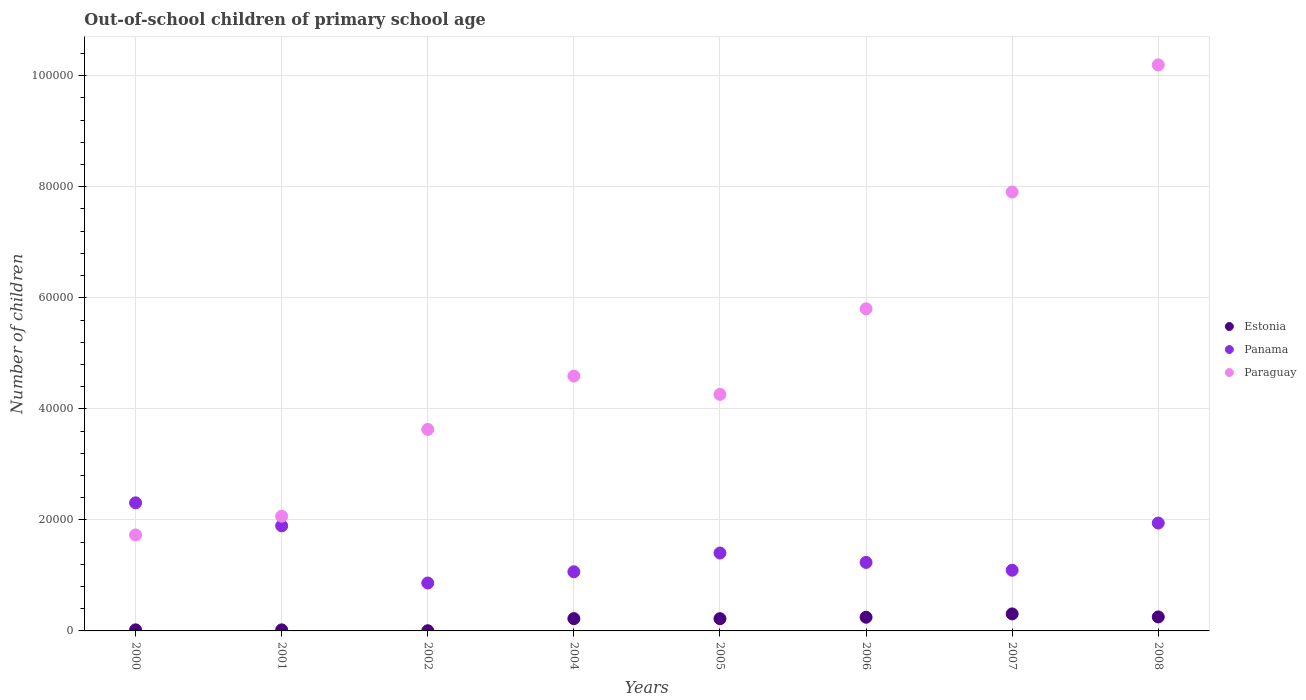Is the number of dotlines equal to the number of legend labels?
Give a very brief answer. Yes. What is the number of out-of-school children in Estonia in 2004?
Your answer should be very brief. 2213. Across all years, what is the maximum number of out-of-school children in Paraguay?
Ensure brevity in your answer.  1.02e+05. Across all years, what is the minimum number of out-of-school children in Estonia?
Your answer should be very brief. 36. What is the total number of out-of-school children in Panama in the graph?
Keep it short and to the point. 1.18e+05. What is the difference between the number of out-of-school children in Estonia in 2001 and that in 2002?
Provide a short and direct response. 156. What is the difference between the number of out-of-school children in Paraguay in 2002 and the number of out-of-school children in Estonia in 2000?
Your answer should be very brief. 3.61e+04. What is the average number of out-of-school children in Estonia per year?
Provide a short and direct response. 1611.12. In the year 2007, what is the difference between the number of out-of-school children in Estonia and number of out-of-school children in Paraguay?
Your response must be concise. -7.60e+04. In how many years, is the number of out-of-school children in Paraguay greater than 60000?
Ensure brevity in your answer.  2. What is the ratio of the number of out-of-school children in Estonia in 2000 to that in 2005?
Your answer should be compact. 0.09. Is the number of out-of-school children in Estonia in 2005 less than that in 2008?
Ensure brevity in your answer.  Yes. What is the difference between the highest and the second highest number of out-of-school children in Estonia?
Offer a very short reply. 546. What is the difference between the highest and the lowest number of out-of-school children in Paraguay?
Make the answer very short. 8.47e+04. Is the number of out-of-school children in Paraguay strictly greater than the number of out-of-school children in Panama over the years?
Keep it short and to the point. No. How many dotlines are there?
Provide a succinct answer. 3. How many years are there in the graph?
Your answer should be very brief. 8. What is the difference between two consecutive major ticks on the Y-axis?
Make the answer very short. 2.00e+04. Are the values on the major ticks of Y-axis written in scientific E-notation?
Ensure brevity in your answer.  No. Does the graph contain grids?
Offer a very short reply. Yes. How many legend labels are there?
Your answer should be very brief. 3. What is the title of the graph?
Offer a very short reply. Out-of-school children of primary school age. What is the label or title of the Y-axis?
Offer a very short reply. Number of children. What is the Number of children in Estonia in 2000?
Your response must be concise. 193. What is the Number of children in Panama in 2000?
Give a very brief answer. 2.31e+04. What is the Number of children of Paraguay in 2000?
Give a very brief answer. 1.73e+04. What is the Number of children of Estonia in 2001?
Keep it short and to the point. 192. What is the Number of children of Panama in 2001?
Keep it short and to the point. 1.89e+04. What is the Number of children in Paraguay in 2001?
Ensure brevity in your answer.  2.07e+04. What is the Number of children in Estonia in 2002?
Offer a very short reply. 36. What is the Number of children of Panama in 2002?
Keep it short and to the point. 8631. What is the Number of children in Paraguay in 2002?
Your response must be concise. 3.63e+04. What is the Number of children of Estonia in 2004?
Provide a succinct answer. 2213. What is the Number of children of Panama in 2004?
Your answer should be very brief. 1.07e+04. What is the Number of children in Paraguay in 2004?
Make the answer very short. 4.59e+04. What is the Number of children in Estonia in 2005?
Your response must be concise. 2203. What is the Number of children in Panama in 2005?
Your answer should be very brief. 1.40e+04. What is the Number of children in Paraguay in 2005?
Make the answer very short. 4.26e+04. What is the Number of children of Estonia in 2006?
Offer a terse response. 2464. What is the Number of children in Panama in 2006?
Ensure brevity in your answer.  1.23e+04. What is the Number of children of Paraguay in 2006?
Your answer should be very brief. 5.80e+04. What is the Number of children in Estonia in 2007?
Provide a succinct answer. 3067. What is the Number of children in Panama in 2007?
Keep it short and to the point. 1.09e+04. What is the Number of children of Paraguay in 2007?
Ensure brevity in your answer.  7.90e+04. What is the Number of children in Estonia in 2008?
Your response must be concise. 2521. What is the Number of children in Panama in 2008?
Your response must be concise. 1.94e+04. What is the Number of children in Paraguay in 2008?
Your answer should be compact. 1.02e+05. Across all years, what is the maximum Number of children of Estonia?
Make the answer very short. 3067. Across all years, what is the maximum Number of children in Panama?
Keep it short and to the point. 2.31e+04. Across all years, what is the maximum Number of children of Paraguay?
Provide a succinct answer. 1.02e+05. Across all years, what is the minimum Number of children of Panama?
Offer a very short reply. 8631. Across all years, what is the minimum Number of children of Paraguay?
Provide a short and direct response. 1.73e+04. What is the total Number of children in Estonia in the graph?
Provide a succinct answer. 1.29e+04. What is the total Number of children of Panama in the graph?
Make the answer very short. 1.18e+05. What is the total Number of children of Paraguay in the graph?
Provide a short and direct response. 4.02e+05. What is the difference between the Number of children in Panama in 2000 and that in 2001?
Your answer should be very brief. 4151. What is the difference between the Number of children of Paraguay in 2000 and that in 2001?
Your response must be concise. -3367. What is the difference between the Number of children in Estonia in 2000 and that in 2002?
Offer a very short reply. 157. What is the difference between the Number of children in Panama in 2000 and that in 2002?
Ensure brevity in your answer.  1.44e+04. What is the difference between the Number of children in Paraguay in 2000 and that in 2002?
Offer a very short reply. -1.90e+04. What is the difference between the Number of children in Estonia in 2000 and that in 2004?
Offer a very short reply. -2020. What is the difference between the Number of children of Panama in 2000 and that in 2004?
Your answer should be compact. 1.24e+04. What is the difference between the Number of children in Paraguay in 2000 and that in 2004?
Provide a short and direct response. -2.86e+04. What is the difference between the Number of children of Estonia in 2000 and that in 2005?
Provide a succinct answer. -2010. What is the difference between the Number of children of Panama in 2000 and that in 2005?
Make the answer very short. 9039. What is the difference between the Number of children in Paraguay in 2000 and that in 2005?
Your answer should be compact. -2.53e+04. What is the difference between the Number of children of Estonia in 2000 and that in 2006?
Keep it short and to the point. -2271. What is the difference between the Number of children of Panama in 2000 and that in 2006?
Make the answer very short. 1.07e+04. What is the difference between the Number of children in Paraguay in 2000 and that in 2006?
Make the answer very short. -4.07e+04. What is the difference between the Number of children in Estonia in 2000 and that in 2007?
Make the answer very short. -2874. What is the difference between the Number of children in Panama in 2000 and that in 2007?
Provide a short and direct response. 1.21e+04. What is the difference between the Number of children in Paraguay in 2000 and that in 2007?
Offer a terse response. -6.18e+04. What is the difference between the Number of children in Estonia in 2000 and that in 2008?
Offer a terse response. -2328. What is the difference between the Number of children of Panama in 2000 and that in 2008?
Offer a very short reply. 3641. What is the difference between the Number of children in Paraguay in 2000 and that in 2008?
Keep it short and to the point. -8.47e+04. What is the difference between the Number of children in Estonia in 2001 and that in 2002?
Keep it short and to the point. 156. What is the difference between the Number of children in Panama in 2001 and that in 2002?
Make the answer very short. 1.03e+04. What is the difference between the Number of children of Paraguay in 2001 and that in 2002?
Your answer should be compact. -1.56e+04. What is the difference between the Number of children of Estonia in 2001 and that in 2004?
Offer a terse response. -2021. What is the difference between the Number of children of Panama in 2001 and that in 2004?
Offer a terse response. 8267. What is the difference between the Number of children of Paraguay in 2001 and that in 2004?
Give a very brief answer. -2.52e+04. What is the difference between the Number of children in Estonia in 2001 and that in 2005?
Offer a very short reply. -2011. What is the difference between the Number of children of Panama in 2001 and that in 2005?
Keep it short and to the point. 4888. What is the difference between the Number of children of Paraguay in 2001 and that in 2005?
Ensure brevity in your answer.  -2.19e+04. What is the difference between the Number of children of Estonia in 2001 and that in 2006?
Ensure brevity in your answer.  -2272. What is the difference between the Number of children in Panama in 2001 and that in 2006?
Your answer should be compact. 6582. What is the difference between the Number of children of Paraguay in 2001 and that in 2006?
Ensure brevity in your answer.  -3.74e+04. What is the difference between the Number of children in Estonia in 2001 and that in 2007?
Ensure brevity in your answer.  -2875. What is the difference between the Number of children in Panama in 2001 and that in 2007?
Offer a terse response. 7992. What is the difference between the Number of children of Paraguay in 2001 and that in 2007?
Give a very brief answer. -5.84e+04. What is the difference between the Number of children in Estonia in 2001 and that in 2008?
Your response must be concise. -2329. What is the difference between the Number of children of Panama in 2001 and that in 2008?
Give a very brief answer. -510. What is the difference between the Number of children of Paraguay in 2001 and that in 2008?
Make the answer very short. -8.13e+04. What is the difference between the Number of children in Estonia in 2002 and that in 2004?
Offer a very short reply. -2177. What is the difference between the Number of children of Panama in 2002 and that in 2004?
Provide a succinct answer. -2023. What is the difference between the Number of children of Paraguay in 2002 and that in 2004?
Offer a very short reply. -9607. What is the difference between the Number of children of Estonia in 2002 and that in 2005?
Provide a succinct answer. -2167. What is the difference between the Number of children in Panama in 2002 and that in 2005?
Provide a short and direct response. -5402. What is the difference between the Number of children of Paraguay in 2002 and that in 2005?
Your answer should be very brief. -6308. What is the difference between the Number of children in Estonia in 2002 and that in 2006?
Give a very brief answer. -2428. What is the difference between the Number of children in Panama in 2002 and that in 2006?
Keep it short and to the point. -3708. What is the difference between the Number of children of Paraguay in 2002 and that in 2006?
Your answer should be compact. -2.17e+04. What is the difference between the Number of children in Estonia in 2002 and that in 2007?
Offer a very short reply. -3031. What is the difference between the Number of children in Panama in 2002 and that in 2007?
Provide a succinct answer. -2298. What is the difference between the Number of children of Paraguay in 2002 and that in 2007?
Ensure brevity in your answer.  -4.28e+04. What is the difference between the Number of children of Estonia in 2002 and that in 2008?
Give a very brief answer. -2485. What is the difference between the Number of children in Panama in 2002 and that in 2008?
Ensure brevity in your answer.  -1.08e+04. What is the difference between the Number of children in Paraguay in 2002 and that in 2008?
Keep it short and to the point. -6.57e+04. What is the difference between the Number of children of Estonia in 2004 and that in 2005?
Give a very brief answer. 10. What is the difference between the Number of children of Panama in 2004 and that in 2005?
Your response must be concise. -3379. What is the difference between the Number of children in Paraguay in 2004 and that in 2005?
Ensure brevity in your answer.  3299. What is the difference between the Number of children of Estonia in 2004 and that in 2006?
Make the answer very short. -251. What is the difference between the Number of children in Panama in 2004 and that in 2006?
Give a very brief answer. -1685. What is the difference between the Number of children of Paraguay in 2004 and that in 2006?
Your answer should be very brief. -1.21e+04. What is the difference between the Number of children of Estonia in 2004 and that in 2007?
Provide a short and direct response. -854. What is the difference between the Number of children in Panama in 2004 and that in 2007?
Provide a succinct answer. -275. What is the difference between the Number of children in Paraguay in 2004 and that in 2007?
Your answer should be very brief. -3.31e+04. What is the difference between the Number of children of Estonia in 2004 and that in 2008?
Ensure brevity in your answer.  -308. What is the difference between the Number of children of Panama in 2004 and that in 2008?
Keep it short and to the point. -8777. What is the difference between the Number of children in Paraguay in 2004 and that in 2008?
Your response must be concise. -5.61e+04. What is the difference between the Number of children of Estonia in 2005 and that in 2006?
Provide a short and direct response. -261. What is the difference between the Number of children in Panama in 2005 and that in 2006?
Your answer should be very brief. 1694. What is the difference between the Number of children in Paraguay in 2005 and that in 2006?
Provide a short and direct response. -1.54e+04. What is the difference between the Number of children in Estonia in 2005 and that in 2007?
Offer a terse response. -864. What is the difference between the Number of children of Panama in 2005 and that in 2007?
Offer a terse response. 3104. What is the difference between the Number of children in Paraguay in 2005 and that in 2007?
Provide a succinct answer. -3.64e+04. What is the difference between the Number of children in Estonia in 2005 and that in 2008?
Provide a short and direct response. -318. What is the difference between the Number of children in Panama in 2005 and that in 2008?
Your answer should be compact. -5398. What is the difference between the Number of children of Paraguay in 2005 and that in 2008?
Offer a very short reply. -5.94e+04. What is the difference between the Number of children in Estonia in 2006 and that in 2007?
Offer a very short reply. -603. What is the difference between the Number of children of Panama in 2006 and that in 2007?
Your answer should be compact. 1410. What is the difference between the Number of children in Paraguay in 2006 and that in 2007?
Your response must be concise. -2.10e+04. What is the difference between the Number of children of Estonia in 2006 and that in 2008?
Provide a short and direct response. -57. What is the difference between the Number of children in Panama in 2006 and that in 2008?
Provide a short and direct response. -7092. What is the difference between the Number of children of Paraguay in 2006 and that in 2008?
Keep it short and to the point. -4.39e+04. What is the difference between the Number of children in Estonia in 2007 and that in 2008?
Make the answer very short. 546. What is the difference between the Number of children in Panama in 2007 and that in 2008?
Provide a short and direct response. -8502. What is the difference between the Number of children of Paraguay in 2007 and that in 2008?
Offer a very short reply. -2.29e+04. What is the difference between the Number of children of Estonia in 2000 and the Number of children of Panama in 2001?
Offer a very short reply. -1.87e+04. What is the difference between the Number of children in Estonia in 2000 and the Number of children in Paraguay in 2001?
Provide a short and direct response. -2.05e+04. What is the difference between the Number of children of Panama in 2000 and the Number of children of Paraguay in 2001?
Provide a succinct answer. 2415. What is the difference between the Number of children in Estonia in 2000 and the Number of children in Panama in 2002?
Make the answer very short. -8438. What is the difference between the Number of children in Estonia in 2000 and the Number of children in Paraguay in 2002?
Make the answer very short. -3.61e+04. What is the difference between the Number of children of Panama in 2000 and the Number of children of Paraguay in 2002?
Keep it short and to the point. -1.32e+04. What is the difference between the Number of children in Estonia in 2000 and the Number of children in Panama in 2004?
Offer a terse response. -1.05e+04. What is the difference between the Number of children in Estonia in 2000 and the Number of children in Paraguay in 2004?
Offer a terse response. -4.57e+04. What is the difference between the Number of children in Panama in 2000 and the Number of children in Paraguay in 2004?
Offer a very short reply. -2.28e+04. What is the difference between the Number of children of Estonia in 2000 and the Number of children of Panama in 2005?
Your answer should be very brief. -1.38e+04. What is the difference between the Number of children of Estonia in 2000 and the Number of children of Paraguay in 2005?
Give a very brief answer. -4.24e+04. What is the difference between the Number of children of Panama in 2000 and the Number of children of Paraguay in 2005?
Provide a short and direct response. -1.95e+04. What is the difference between the Number of children in Estonia in 2000 and the Number of children in Panama in 2006?
Your answer should be compact. -1.21e+04. What is the difference between the Number of children of Estonia in 2000 and the Number of children of Paraguay in 2006?
Make the answer very short. -5.78e+04. What is the difference between the Number of children of Panama in 2000 and the Number of children of Paraguay in 2006?
Keep it short and to the point. -3.49e+04. What is the difference between the Number of children of Estonia in 2000 and the Number of children of Panama in 2007?
Your answer should be compact. -1.07e+04. What is the difference between the Number of children in Estonia in 2000 and the Number of children in Paraguay in 2007?
Give a very brief answer. -7.89e+04. What is the difference between the Number of children in Panama in 2000 and the Number of children in Paraguay in 2007?
Your answer should be very brief. -5.60e+04. What is the difference between the Number of children in Estonia in 2000 and the Number of children in Panama in 2008?
Offer a very short reply. -1.92e+04. What is the difference between the Number of children in Estonia in 2000 and the Number of children in Paraguay in 2008?
Your response must be concise. -1.02e+05. What is the difference between the Number of children in Panama in 2000 and the Number of children in Paraguay in 2008?
Make the answer very short. -7.89e+04. What is the difference between the Number of children of Estonia in 2001 and the Number of children of Panama in 2002?
Offer a very short reply. -8439. What is the difference between the Number of children in Estonia in 2001 and the Number of children in Paraguay in 2002?
Your response must be concise. -3.61e+04. What is the difference between the Number of children in Panama in 2001 and the Number of children in Paraguay in 2002?
Ensure brevity in your answer.  -1.74e+04. What is the difference between the Number of children in Estonia in 2001 and the Number of children in Panama in 2004?
Offer a terse response. -1.05e+04. What is the difference between the Number of children of Estonia in 2001 and the Number of children of Paraguay in 2004?
Provide a succinct answer. -4.57e+04. What is the difference between the Number of children in Panama in 2001 and the Number of children in Paraguay in 2004?
Offer a terse response. -2.70e+04. What is the difference between the Number of children in Estonia in 2001 and the Number of children in Panama in 2005?
Provide a succinct answer. -1.38e+04. What is the difference between the Number of children of Estonia in 2001 and the Number of children of Paraguay in 2005?
Your answer should be compact. -4.24e+04. What is the difference between the Number of children of Panama in 2001 and the Number of children of Paraguay in 2005?
Your answer should be compact. -2.37e+04. What is the difference between the Number of children of Estonia in 2001 and the Number of children of Panama in 2006?
Give a very brief answer. -1.21e+04. What is the difference between the Number of children of Estonia in 2001 and the Number of children of Paraguay in 2006?
Your response must be concise. -5.78e+04. What is the difference between the Number of children of Panama in 2001 and the Number of children of Paraguay in 2006?
Give a very brief answer. -3.91e+04. What is the difference between the Number of children of Estonia in 2001 and the Number of children of Panama in 2007?
Ensure brevity in your answer.  -1.07e+04. What is the difference between the Number of children in Estonia in 2001 and the Number of children in Paraguay in 2007?
Keep it short and to the point. -7.89e+04. What is the difference between the Number of children in Panama in 2001 and the Number of children in Paraguay in 2007?
Your answer should be compact. -6.01e+04. What is the difference between the Number of children in Estonia in 2001 and the Number of children in Panama in 2008?
Offer a terse response. -1.92e+04. What is the difference between the Number of children in Estonia in 2001 and the Number of children in Paraguay in 2008?
Your response must be concise. -1.02e+05. What is the difference between the Number of children of Panama in 2001 and the Number of children of Paraguay in 2008?
Your response must be concise. -8.30e+04. What is the difference between the Number of children in Estonia in 2002 and the Number of children in Panama in 2004?
Your answer should be compact. -1.06e+04. What is the difference between the Number of children of Estonia in 2002 and the Number of children of Paraguay in 2004?
Offer a very short reply. -4.59e+04. What is the difference between the Number of children in Panama in 2002 and the Number of children in Paraguay in 2004?
Keep it short and to the point. -3.73e+04. What is the difference between the Number of children of Estonia in 2002 and the Number of children of Panama in 2005?
Offer a terse response. -1.40e+04. What is the difference between the Number of children in Estonia in 2002 and the Number of children in Paraguay in 2005?
Your answer should be compact. -4.26e+04. What is the difference between the Number of children of Panama in 2002 and the Number of children of Paraguay in 2005?
Give a very brief answer. -3.40e+04. What is the difference between the Number of children in Estonia in 2002 and the Number of children in Panama in 2006?
Make the answer very short. -1.23e+04. What is the difference between the Number of children of Estonia in 2002 and the Number of children of Paraguay in 2006?
Your response must be concise. -5.80e+04. What is the difference between the Number of children in Panama in 2002 and the Number of children in Paraguay in 2006?
Offer a terse response. -4.94e+04. What is the difference between the Number of children of Estonia in 2002 and the Number of children of Panama in 2007?
Your response must be concise. -1.09e+04. What is the difference between the Number of children of Estonia in 2002 and the Number of children of Paraguay in 2007?
Provide a short and direct response. -7.90e+04. What is the difference between the Number of children of Panama in 2002 and the Number of children of Paraguay in 2007?
Offer a terse response. -7.04e+04. What is the difference between the Number of children in Estonia in 2002 and the Number of children in Panama in 2008?
Make the answer very short. -1.94e+04. What is the difference between the Number of children of Estonia in 2002 and the Number of children of Paraguay in 2008?
Provide a succinct answer. -1.02e+05. What is the difference between the Number of children in Panama in 2002 and the Number of children in Paraguay in 2008?
Ensure brevity in your answer.  -9.33e+04. What is the difference between the Number of children of Estonia in 2004 and the Number of children of Panama in 2005?
Offer a terse response. -1.18e+04. What is the difference between the Number of children of Estonia in 2004 and the Number of children of Paraguay in 2005?
Your answer should be compact. -4.04e+04. What is the difference between the Number of children of Panama in 2004 and the Number of children of Paraguay in 2005?
Offer a terse response. -3.20e+04. What is the difference between the Number of children in Estonia in 2004 and the Number of children in Panama in 2006?
Make the answer very short. -1.01e+04. What is the difference between the Number of children in Estonia in 2004 and the Number of children in Paraguay in 2006?
Offer a terse response. -5.58e+04. What is the difference between the Number of children of Panama in 2004 and the Number of children of Paraguay in 2006?
Offer a terse response. -4.74e+04. What is the difference between the Number of children in Estonia in 2004 and the Number of children in Panama in 2007?
Provide a succinct answer. -8716. What is the difference between the Number of children of Estonia in 2004 and the Number of children of Paraguay in 2007?
Give a very brief answer. -7.68e+04. What is the difference between the Number of children in Panama in 2004 and the Number of children in Paraguay in 2007?
Give a very brief answer. -6.84e+04. What is the difference between the Number of children of Estonia in 2004 and the Number of children of Panama in 2008?
Your answer should be compact. -1.72e+04. What is the difference between the Number of children in Estonia in 2004 and the Number of children in Paraguay in 2008?
Ensure brevity in your answer.  -9.97e+04. What is the difference between the Number of children of Panama in 2004 and the Number of children of Paraguay in 2008?
Make the answer very short. -9.13e+04. What is the difference between the Number of children of Estonia in 2005 and the Number of children of Panama in 2006?
Give a very brief answer. -1.01e+04. What is the difference between the Number of children in Estonia in 2005 and the Number of children in Paraguay in 2006?
Keep it short and to the point. -5.58e+04. What is the difference between the Number of children of Panama in 2005 and the Number of children of Paraguay in 2006?
Make the answer very short. -4.40e+04. What is the difference between the Number of children of Estonia in 2005 and the Number of children of Panama in 2007?
Offer a very short reply. -8726. What is the difference between the Number of children of Estonia in 2005 and the Number of children of Paraguay in 2007?
Make the answer very short. -7.68e+04. What is the difference between the Number of children of Panama in 2005 and the Number of children of Paraguay in 2007?
Give a very brief answer. -6.50e+04. What is the difference between the Number of children of Estonia in 2005 and the Number of children of Panama in 2008?
Offer a very short reply. -1.72e+04. What is the difference between the Number of children of Estonia in 2005 and the Number of children of Paraguay in 2008?
Keep it short and to the point. -9.98e+04. What is the difference between the Number of children in Panama in 2005 and the Number of children in Paraguay in 2008?
Your answer should be compact. -8.79e+04. What is the difference between the Number of children of Estonia in 2006 and the Number of children of Panama in 2007?
Offer a terse response. -8465. What is the difference between the Number of children in Estonia in 2006 and the Number of children in Paraguay in 2007?
Your response must be concise. -7.66e+04. What is the difference between the Number of children of Panama in 2006 and the Number of children of Paraguay in 2007?
Give a very brief answer. -6.67e+04. What is the difference between the Number of children in Estonia in 2006 and the Number of children in Panama in 2008?
Provide a short and direct response. -1.70e+04. What is the difference between the Number of children of Estonia in 2006 and the Number of children of Paraguay in 2008?
Provide a succinct answer. -9.95e+04. What is the difference between the Number of children of Panama in 2006 and the Number of children of Paraguay in 2008?
Your answer should be compact. -8.96e+04. What is the difference between the Number of children of Estonia in 2007 and the Number of children of Panama in 2008?
Give a very brief answer. -1.64e+04. What is the difference between the Number of children in Estonia in 2007 and the Number of children in Paraguay in 2008?
Provide a short and direct response. -9.89e+04. What is the difference between the Number of children of Panama in 2007 and the Number of children of Paraguay in 2008?
Your answer should be very brief. -9.10e+04. What is the average Number of children in Estonia per year?
Your answer should be compact. 1611.12. What is the average Number of children in Panama per year?
Keep it short and to the point. 1.48e+04. What is the average Number of children in Paraguay per year?
Your response must be concise. 5.02e+04. In the year 2000, what is the difference between the Number of children in Estonia and Number of children in Panama?
Your response must be concise. -2.29e+04. In the year 2000, what is the difference between the Number of children of Estonia and Number of children of Paraguay?
Your answer should be very brief. -1.71e+04. In the year 2000, what is the difference between the Number of children of Panama and Number of children of Paraguay?
Make the answer very short. 5782. In the year 2001, what is the difference between the Number of children in Estonia and Number of children in Panama?
Provide a succinct answer. -1.87e+04. In the year 2001, what is the difference between the Number of children of Estonia and Number of children of Paraguay?
Your answer should be compact. -2.05e+04. In the year 2001, what is the difference between the Number of children in Panama and Number of children in Paraguay?
Your answer should be compact. -1736. In the year 2002, what is the difference between the Number of children of Estonia and Number of children of Panama?
Provide a succinct answer. -8595. In the year 2002, what is the difference between the Number of children in Estonia and Number of children in Paraguay?
Offer a very short reply. -3.63e+04. In the year 2002, what is the difference between the Number of children in Panama and Number of children in Paraguay?
Offer a terse response. -2.77e+04. In the year 2004, what is the difference between the Number of children in Estonia and Number of children in Panama?
Your response must be concise. -8441. In the year 2004, what is the difference between the Number of children in Estonia and Number of children in Paraguay?
Keep it short and to the point. -4.37e+04. In the year 2004, what is the difference between the Number of children in Panama and Number of children in Paraguay?
Your response must be concise. -3.52e+04. In the year 2005, what is the difference between the Number of children of Estonia and Number of children of Panama?
Keep it short and to the point. -1.18e+04. In the year 2005, what is the difference between the Number of children of Estonia and Number of children of Paraguay?
Offer a very short reply. -4.04e+04. In the year 2005, what is the difference between the Number of children in Panama and Number of children in Paraguay?
Make the answer very short. -2.86e+04. In the year 2006, what is the difference between the Number of children in Estonia and Number of children in Panama?
Give a very brief answer. -9875. In the year 2006, what is the difference between the Number of children of Estonia and Number of children of Paraguay?
Keep it short and to the point. -5.56e+04. In the year 2006, what is the difference between the Number of children of Panama and Number of children of Paraguay?
Your answer should be compact. -4.57e+04. In the year 2007, what is the difference between the Number of children of Estonia and Number of children of Panama?
Your response must be concise. -7862. In the year 2007, what is the difference between the Number of children of Estonia and Number of children of Paraguay?
Offer a very short reply. -7.60e+04. In the year 2007, what is the difference between the Number of children of Panama and Number of children of Paraguay?
Your answer should be compact. -6.81e+04. In the year 2008, what is the difference between the Number of children in Estonia and Number of children in Panama?
Your answer should be very brief. -1.69e+04. In the year 2008, what is the difference between the Number of children of Estonia and Number of children of Paraguay?
Your answer should be compact. -9.94e+04. In the year 2008, what is the difference between the Number of children of Panama and Number of children of Paraguay?
Give a very brief answer. -8.25e+04. What is the ratio of the Number of children in Estonia in 2000 to that in 2001?
Your answer should be very brief. 1.01. What is the ratio of the Number of children in Panama in 2000 to that in 2001?
Keep it short and to the point. 1.22. What is the ratio of the Number of children of Paraguay in 2000 to that in 2001?
Your answer should be compact. 0.84. What is the ratio of the Number of children in Estonia in 2000 to that in 2002?
Provide a succinct answer. 5.36. What is the ratio of the Number of children of Panama in 2000 to that in 2002?
Make the answer very short. 2.67. What is the ratio of the Number of children in Paraguay in 2000 to that in 2002?
Keep it short and to the point. 0.48. What is the ratio of the Number of children in Estonia in 2000 to that in 2004?
Keep it short and to the point. 0.09. What is the ratio of the Number of children of Panama in 2000 to that in 2004?
Provide a succinct answer. 2.17. What is the ratio of the Number of children of Paraguay in 2000 to that in 2004?
Offer a terse response. 0.38. What is the ratio of the Number of children in Estonia in 2000 to that in 2005?
Give a very brief answer. 0.09. What is the ratio of the Number of children of Panama in 2000 to that in 2005?
Your answer should be very brief. 1.64. What is the ratio of the Number of children in Paraguay in 2000 to that in 2005?
Ensure brevity in your answer.  0.41. What is the ratio of the Number of children of Estonia in 2000 to that in 2006?
Your answer should be very brief. 0.08. What is the ratio of the Number of children of Panama in 2000 to that in 2006?
Keep it short and to the point. 1.87. What is the ratio of the Number of children of Paraguay in 2000 to that in 2006?
Make the answer very short. 0.3. What is the ratio of the Number of children in Estonia in 2000 to that in 2007?
Give a very brief answer. 0.06. What is the ratio of the Number of children of Panama in 2000 to that in 2007?
Your answer should be very brief. 2.11. What is the ratio of the Number of children of Paraguay in 2000 to that in 2007?
Provide a short and direct response. 0.22. What is the ratio of the Number of children in Estonia in 2000 to that in 2008?
Ensure brevity in your answer.  0.08. What is the ratio of the Number of children in Panama in 2000 to that in 2008?
Your response must be concise. 1.19. What is the ratio of the Number of children of Paraguay in 2000 to that in 2008?
Offer a terse response. 0.17. What is the ratio of the Number of children in Estonia in 2001 to that in 2002?
Your answer should be very brief. 5.33. What is the ratio of the Number of children of Panama in 2001 to that in 2002?
Provide a succinct answer. 2.19. What is the ratio of the Number of children in Paraguay in 2001 to that in 2002?
Offer a very short reply. 0.57. What is the ratio of the Number of children in Estonia in 2001 to that in 2004?
Ensure brevity in your answer.  0.09. What is the ratio of the Number of children in Panama in 2001 to that in 2004?
Your answer should be very brief. 1.78. What is the ratio of the Number of children of Paraguay in 2001 to that in 2004?
Your answer should be very brief. 0.45. What is the ratio of the Number of children of Estonia in 2001 to that in 2005?
Your answer should be compact. 0.09. What is the ratio of the Number of children of Panama in 2001 to that in 2005?
Ensure brevity in your answer.  1.35. What is the ratio of the Number of children in Paraguay in 2001 to that in 2005?
Your answer should be compact. 0.48. What is the ratio of the Number of children of Estonia in 2001 to that in 2006?
Your response must be concise. 0.08. What is the ratio of the Number of children in Panama in 2001 to that in 2006?
Keep it short and to the point. 1.53. What is the ratio of the Number of children in Paraguay in 2001 to that in 2006?
Your answer should be compact. 0.36. What is the ratio of the Number of children in Estonia in 2001 to that in 2007?
Offer a terse response. 0.06. What is the ratio of the Number of children in Panama in 2001 to that in 2007?
Ensure brevity in your answer.  1.73. What is the ratio of the Number of children in Paraguay in 2001 to that in 2007?
Your answer should be very brief. 0.26. What is the ratio of the Number of children of Estonia in 2001 to that in 2008?
Give a very brief answer. 0.08. What is the ratio of the Number of children of Panama in 2001 to that in 2008?
Offer a very short reply. 0.97. What is the ratio of the Number of children in Paraguay in 2001 to that in 2008?
Provide a succinct answer. 0.2. What is the ratio of the Number of children of Estonia in 2002 to that in 2004?
Offer a very short reply. 0.02. What is the ratio of the Number of children of Panama in 2002 to that in 2004?
Provide a succinct answer. 0.81. What is the ratio of the Number of children of Paraguay in 2002 to that in 2004?
Keep it short and to the point. 0.79. What is the ratio of the Number of children of Estonia in 2002 to that in 2005?
Give a very brief answer. 0.02. What is the ratio of the Number of children of Panama in 2002 to that in 2005?
Your answer should be very brief. 0.62. What is the ratio of the Number of children in Paraguay in 2002 to that in 2005?
Your answer should be very brief. 0.85. What is the ratio of the Number of children of Estonia in 2002 to that in 2006?
Offer a very short reply. 0.01. What is the ratio of the Number of children in Panama in 2002 to that in 2006?
Provide a succinct answer. 0.7. What is the ratio of the Number of children in Paraguay in 2002 to that in 2006?
Offer a very short reply. 0.63. What is the ratio of the Number of children of Estonia in 2002 to that in 2007?
Make the answer very short. 0.01. What is the ratio of the Number of children of Panama in 2002 to that in 2007?
Offer a very short reply. 0.79. What is the ratio of the Number of children of Paraguay in 2002 to that in 2007?
Provide a short and direct response. 0.46. What is the ratio of the Number of children of Estonia in 2002 to that in 2008?
Your answer should be very brief. 0.01. What is the ratio of the Number of children in Panama in 2002 to that in 2008?
Offer a terse response. 0.44. What is the ratio of the Number of children of Paraguay in 2002 to that in 2008?
Offer a very short reply. 0.36. What is the ratio of the Number of children of Panama in 2004 to that in 2005?
Keep it short and to the point. 0.76. What is the ratio of the Number of children of Paraguay in 2004 to that in 2005?
Keep it short and to the point. 1.08. What is the ratio of the Number of children of Estonia in 2004 to that in 2006?
Provide a short and direct response. 0.9. What is the ratio of the Number of children of Panama in 2004 to that in 2006?
Offer a terse response. 0.86. What is the ratio of the Number of children of Paraguay in 2004 to that in 2006?
Ensure brevity in your answer.  0.79. What is the ratio of the Number of children in Estonia in 2004 to that in 2007?
Your response must be concise. 0.72. What is the ratio of the Number of children of Panama in 2004 to that in 2007?
Your response must be concise. 0.97. What is the ratio of the Number of children of Paraguay in 2004 to that in 2007?
Make the answer very short. 0.58. What is the ratio of the Number of children in Estonia in 2004 to that in 2008?
Offer a terse response. 0.88. What is the ratio of the Number of children in Panama in 2004 to that in 2008?
Your answer should be compact. 0.55. What is the ratio of the Number of children of Paraguay in 2004 to that in 2008?
Ensure brevity in your answer.  0.45. What is the ratio of the Number of children of Estonia in 2005 to that in 2006?
Offer a terse response. 0.89. What is the ratio of the Number of children of Panama in 2005 to that in 2006?
Provide a short and direct response. 1.14. What is the ratio of the Number of children in Paraguay in 2005 to that in 2006?
Keep it short and to the point. 0.73. What is the ratio of the Number of children of Estonia in 2005 to that in 2007?
Give a very brief answer. 0.72. What is the ratio of the Number of children in Panama in 2005 to that in 2007?
Your response must be concise. 1.28. What is the ratio of the Number of children in Paraguay in 2005 to that in 2007?
Your answer should be compact. 0.54. What is the ratio of the Number of children of Estonia in 2005 to that in 2008?
Your answer should be compact. 0.87. What is the ratio of the Number of children in Panama in 2005 to that in 2008?
Provide a short and direct response. 0.72. What is the ratio of the Number of children of Paraguay in 2005 to that in 2008?
Give a very brief answer. 0.42. What is the ratio of the Number of children of Estonia in 2006 to that in 2007?
Make the answer very short. 0.8. What is the ratio of the Number of children in Panama in 2006 to that in 2007?
Make the answer very short. 1.13. What is the ratio of the Number of children in Paraguay in 2006 to that in 2007?
Offer a terse response. 0.73. What is the ratio of the Number of children in Estonia in 2006 to that in 2008?
Offer a terse response. 0.98. What is the ratio of the Number of children of Panama in 2006 to that in 2008?
Your answer should be compact. 0.64. What is the ratio of the Number of children in Paraguay in 2006 to that in 2008?
Your answer should be very brief. 0.57. What is the ratio of the Number of children in Estonia in 2007 to that in 2008?
Provide a succinct answer. 1.22. What is the ratio of the Number of children in Panama in 2007 to that in 2008?
Offer a terse response. 0.56. What is the ratio of the Number of children of Paraguay in 2007 to that in 2008?
Offer a very short reply. 0.78. What is the difference between the highest and the second highest Number of children in Estonia?
Make the answer very short. 546. What is the difference between the highest and the second highest Number of children in Panama?
Give a very brief answer. 3641. What is the difference between the highest and the second highest Number of children in Paraguay?
Your response must be concise. 2.29e+04. What is the difference between the highest and the lowest Number of children in Estonia?
Your response must be concise. 3031. What is the difference between the highest and the lowest Number of children in Panama?
Offer a very short reply. 1.44e+04. What is the difference between the highest and the lowest Number of children of Paraguay?
Provide a short and direct response. 8.47e+04. 